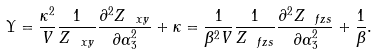Convert formula to latex. <formula><loc_0><loc_0><loc_500><loc_500>\Upsilon = \frac { \kappa ^ { 2 } } { V } \frac { 1 } { Z _ { \ x y } } \frac { \partial ^ { 2 } Z _ { \ x y } } { \partial \alpha _ { 3 } ^ { 2 } } + \kappa = \frac { 1 } { \beta ^ { 2 } V } \frac { 1 } { Z _ { \ f z s } } \frac { \partial ^ { 2 } Z _ { \ f z s } } { \partial \alpha _ { 3 } ^ { 2 } } + \frac { 1 } { \beta } .</formula> 